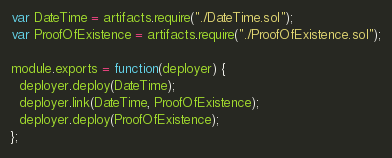<code> <loc_0><loc_0><loc_500><loc_500><_JavaScript_>var DateTime = artifacts.require("./DateTime.sol");
var ProofOfExistence = artifacts.require("./ProofOfExistence.sol");

module.exports = function(deployer) {
  deployer.deploy(DateTime);
  deployer.link(DateTime, ProofOfExistence);
  deployer.deploy(ProofOfExistence);
};
</code> 